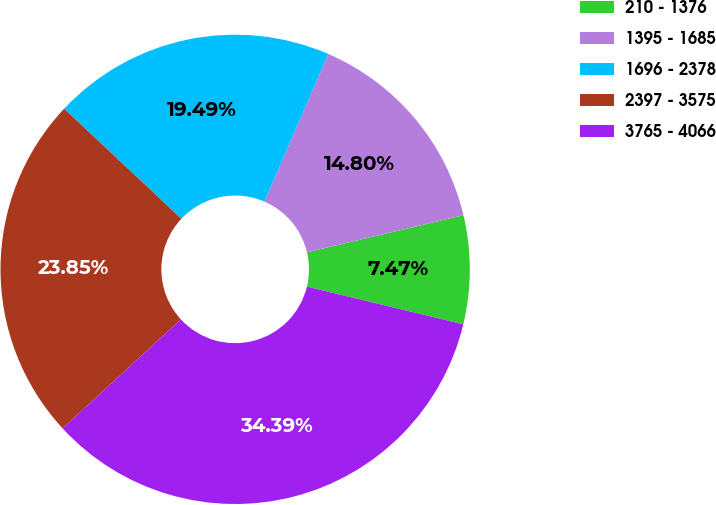<chart> <loc_0><loc_0><loc_500><loc_500><pie_chart><fcel>210 - 1376<fcel>1395 - 1685<fcel>1696 - 2378<fcel>2397 - 3575<fcel>3765 - 4066<nl><fcel>7.47%<fcel>14.8%<fcel>19.49%<fcel>23.85%<fcel>34.39%<nl></chart> 